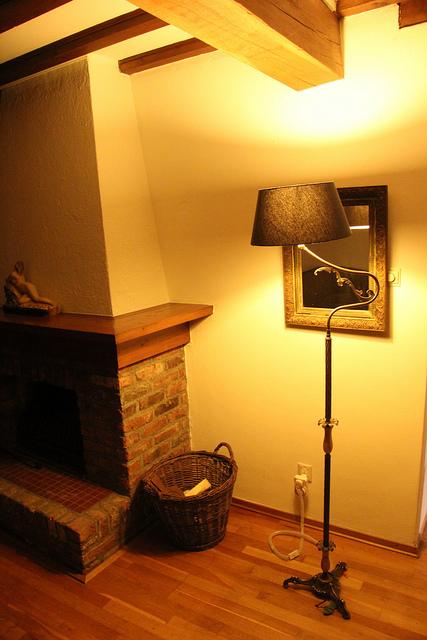What room is this?
Answer briefly. Living room. What is the fireplace made of?
Keep it brief. Brick. How does lighting affect the mood of a room?
Be succinct. Relaxing. 